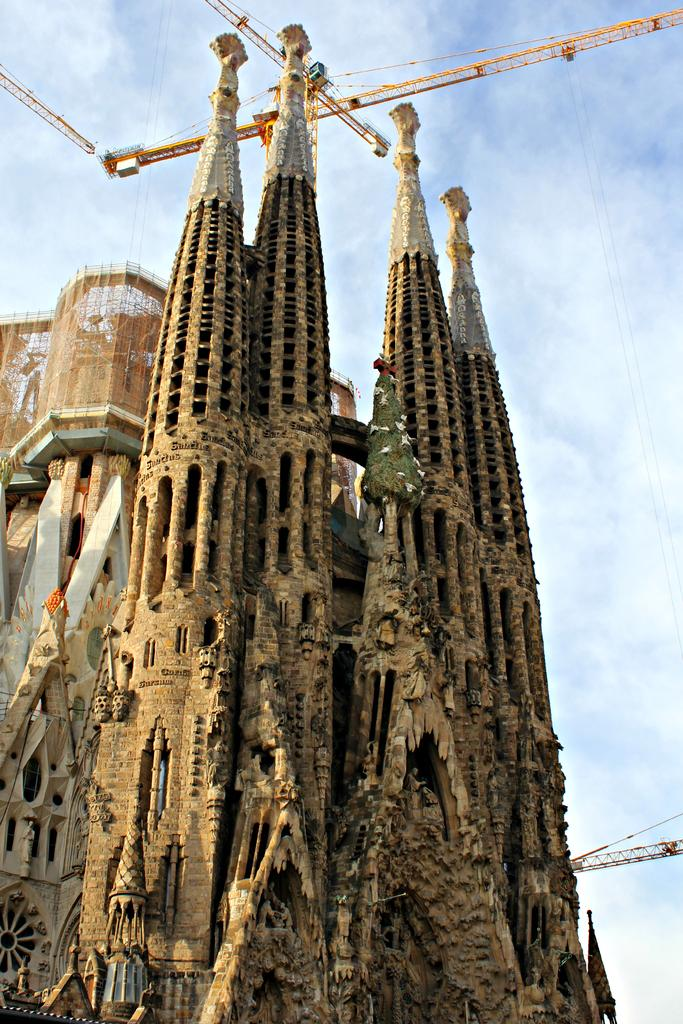What is the main subject in the foreground of the image? There is a building in the foreground of the image. What is happening in the background of the image? There is a building under construction in the background of the image. What type of equipment can be seen at the top of the image? Heavy machinery is present at the top of the image. How would you describe the sky in the image? The sky is partially cloudy. How many trees can be seen interacting with the squirrel in the image? There are no trees or squirrels present in the image. What type of net is being used to catch the fish in the image? There is no net or fish present in the image. 